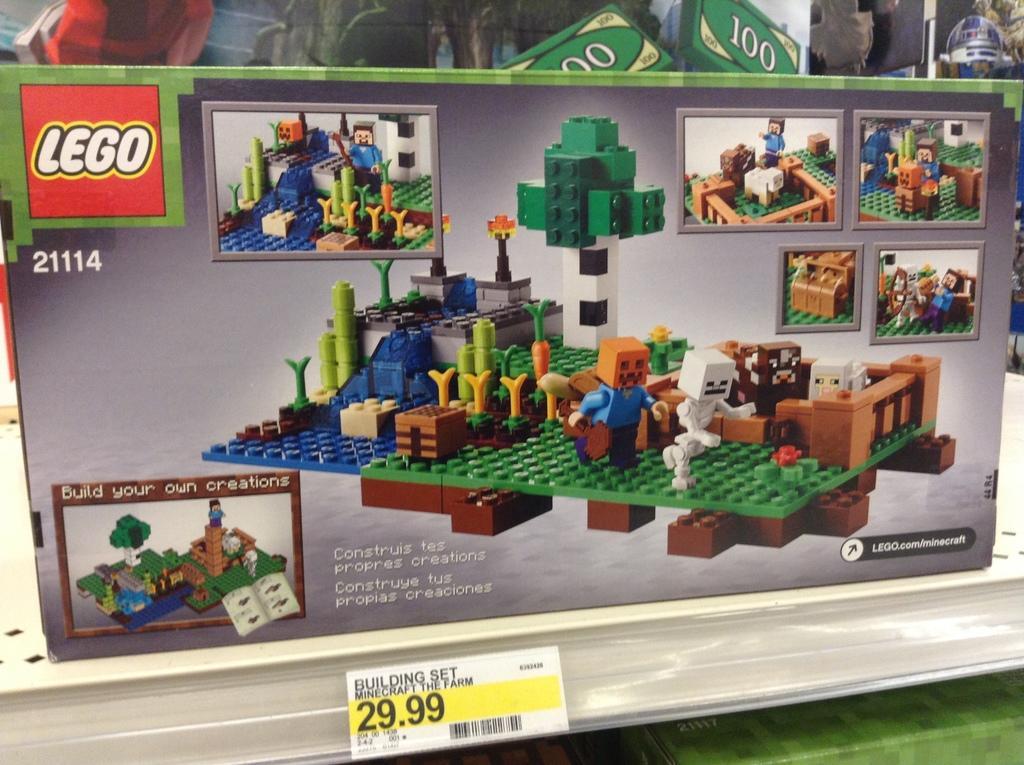How would you summarize this image in a sentence or two? In the center of the image we can see building made up of lego bricks. At the bottom of the image we can see bar code and some text are there. 